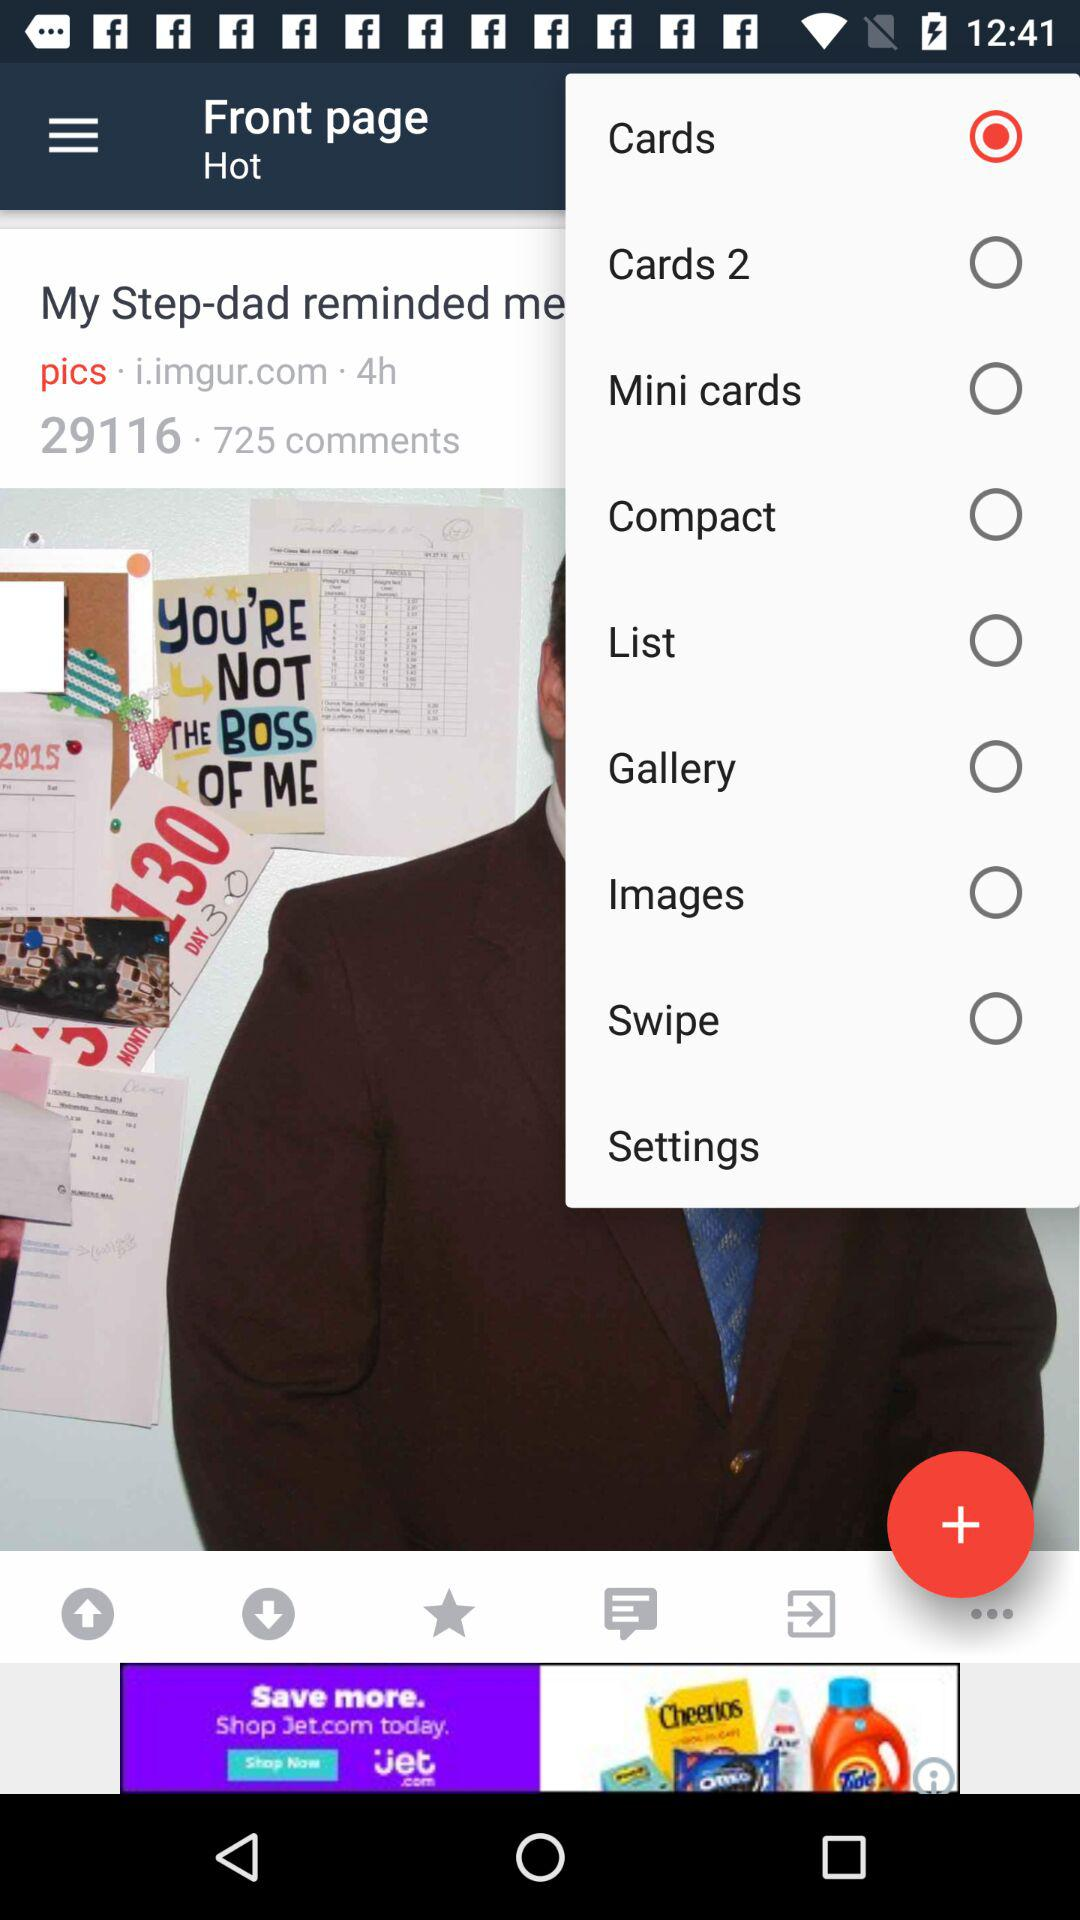Which option is selected among all the options? The selected option is "Cards". 